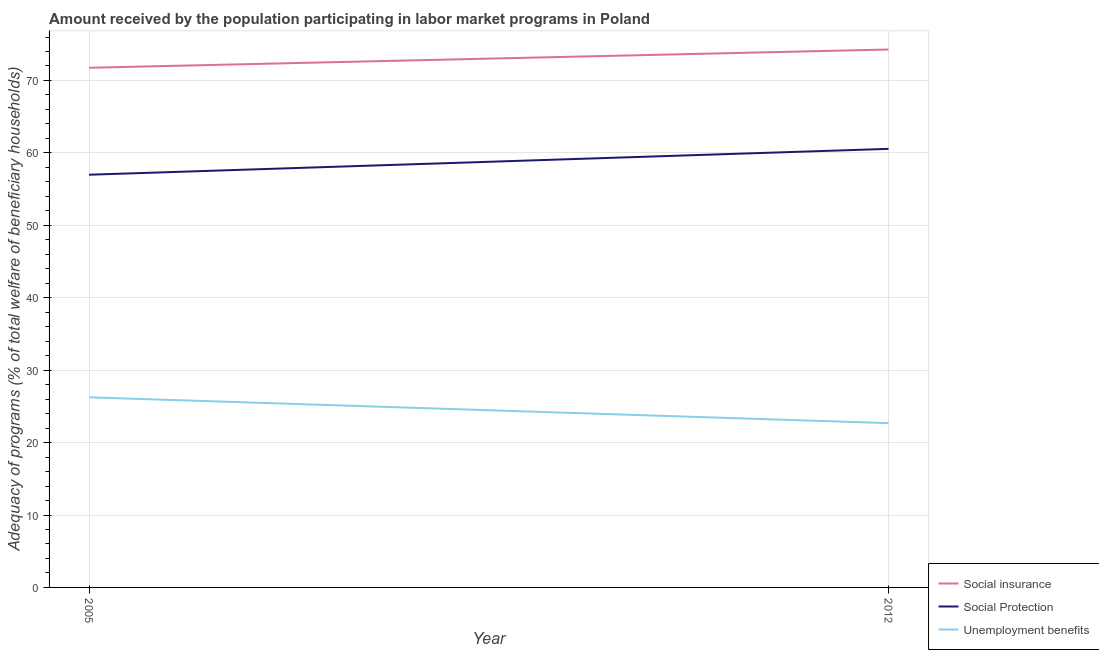How many different coloured lines are there?
Your answer should be compact. 3. Is the number of lines equal to the number of legend labels?
Offer a very short reply. Yes. What is the amount received by the population participating in unemployment benefits programs in 2012?
Provide a short and direct response. 22.68. Across all years, what is the maximum amount received by the population participating in unemployment benefits programs?
Ensure brevity in your answer.  26.25. Across all years, what is the minimum amount received by the population participating in social protection programs?
Offer a terse response. 56.99. In which year was the amount received by the population participating in social protection programs maximum?
Your response must be concise. 2012. In which year was the amount received by the population participating in social insurance programs minimum?
Offer a very short reply. 2005. What is the total amount received by the population participating in unemployment benefits programs in the graph?
Make the answer very short. 48.93. What is the difference between the amount received by the population participating in social protection programs in 2005 and that in 2012?
Your answer should be very brief. -3.57. What is the difference between the amount received by the population participating in unemployment benefits programs in 2012 and the amount received by the population participating in social insurance programs in 2005?
Offer a terse response. -49.07. What is the average amount received by the population participating in social protection programs per year?
Provide a succinct answer. 58.77. In the year 2012, what is the difference between the amount received by the population participating in social insurance programs and amount received by the population participating in social protection programs?
Make the answer very short. 13.72. What is the ratio of the amount received by the population participating in social protection programs in 2005 to that in 2012?
Your response must be concise. 0.94. Is it the case that in every year, the sum of the amount received by the population participating in social insurance programs and amount received by the population participating in social protection programs is greater than the amount received by the population participating in unemployment benefits programs?
Give a very brief answer. Yes. Does the amount received by the population participating in social insurance programs monotonically increase over the years?
Provide a short and direct response. Yes. Is the amount received by the population participating in social protection programs strictly greater than the amount received by the population participating in social insurance programs over the years?
Your response must be concise. No. How many lines are there?
Your answer should be very brief. 3. How many years are there in the graph?
Provide a succinct answer. 2. Are the values on the major ticks of Y-axis written in scientific E-notation?
Your answer should be very brief. No. What is the title of the graph?
Offer a very short reply. Amount received by the population participating in labor market programs in Poland. What is the label or title of the Y-axis?
Your answer should be very brief. Adequacy of programs (% of total welfare of beneficiary households). What is the Adequacy of programs (% of total welfare of beneficiary households) in Social insurance in 2005?
Provide a succinct answer. 71.75. What is the Adequacy of programs (% of total welfare of beneficiary households) of Social Protection in 2005?
Offer a terse response. 56.99. What is the Adequacy of programs (% of total welfare of beneficiary households) in Unemployment benefits in 2005?
Give a very brief answer. 26.25. What is the Adequacy of programs (% of total welfare of beneficiary households) in Social insurance in 2012?
Offer a very short reply. 74.28. What is the Adequacy of programs (% of total welfare of beneficiary households) of Social Protection in 2012?
Provide a short and direct response. 60.56. What is the Adequacy of programs (% of total welfare of beneficiary households) of Unemployment benefits in 2012?
Keep it short and to the point. 22.68. Across all years, what is the maximum Adequacy of programs (% of total welfare of beneficiary households) in Social insurance?
Your response must be concise. 74.28. Across all years, what is the maximum Adequacy of programs (% of total welfare of beneficiary households) of Social Protection?
Your response must be concise. 60.56. Across all years, what is the maximum Adequacy of programs (% of total welfare of beneficiary households) of Unemployment benefits?
Give a very brief answer. 26.25. Across all years, what is the minimum Adequacy of programs (% of total welfare of beneficiary households) of Social insurance?
Your answer should be very brief. 71.75. Across all years, what is the minimum Adequacy of programs (% of total welfare of beneficiary households) of Social Protection?
Give a very brief answer. 56.99. Across all years, what is the minimum Adequacy of programs (% of total welfare of beneficiary households) in Unemployment benefits?
Offer a very short reply. 22.68. What is the total Adequacy of programs (% of total welfare of beneficiary households) of Social insurance in the graph?
Keep it short and to the point. 146.03. What is the total Adequacy of programs (% of total welfare of beneficiary households) of Social Protection in the graph?
Give a very brief answer. 117.54. What is the total Adequacy of programs (% of total welfare of beneficiary households) of Unemployment benefits in the graph?
Your response must be concise. 48.93. What is the difference between the Adequacy of programs (% of total welfare of beneficiary households) in Social insurance in 2005 and that in 2012?
Ensure brevity in your answer.  -2.52. What is the difference between the Adequacy of programs (% of total welfare of beneficiary households) of Social Protection in 2005 and that in 2012?
Offer a terse response. -3.57. What is the difference between the Adequacy of programs (% of total welfare of beneficiary households) of Unemployment benefits in 2005 and that in 2012?
Ensure brevity in your answer.  3.57. What is the difference between the Adequacy of programs (% of total welfare of beneficiary households) in Social insurance in 2005 and the Adequacy of programs (% of total welfare of beneficiary households) in Social Protection in 2012?
Provide a succinct answer. 11.2. What is the difference between the Adequacy of programs (% of total welfare of beneficiary households) in Social insurance in 2005 and the Adequacy of programs (% of total welfare of beneficiary households) in Unemployment benefits in 2012?
Give a very brief answer. 49.07. What is the difference between the Adequacy of programs (% of total welfare of beneficiary households) in Social Protection in 2005 and the Adequacy of programs (% of total welfare of beneficiary households) in Unemployment benefits in 2012?
Offer a terse response. 34.3. What is the average Adequacy of programs (% of total welfare of beneficiary households) in Social insurance per year?
Ensure brevity in your answer.  73.01. What is the average Adequacy of programs (% of total welfare of beneficiary households) in Social Protection per year?
Your answer should be compact. 58.77. What is the average Adequacy of programs (% of total welfare of beneficiary households) of Unemployment benefits per year?
Keep it short and to the point. 24.47. In the year 2005, what is the difference between the Adequacy of programs (% of total welfare of beneficiary households) in Social insurance and Adequacy of programs (% of total welfare of beneficiary households) in Social Protection?
Offer a terse response. 14.77. In the year 2005, what is the difference between the Adequacy of programs (% of total welfare of beneficiary households) of Social insurance and Adequacy of programs (% of total welfare of beneficiary households) of Unemployment benefits?
Offer a very short reply. 45.5. In the year 2005, what is the difference between the Adequacy of programs (% of total welfare of beneficiary households) in Social Protection and Adequacy of programs (% of total welfare of beneficiary households) in Unemployment benefits?
Give a very brief answer. 30.74. In the year 2012, what is the difference between the Adequacy of programs (% of total welfare of beneficiary households) in Social insurance and Adequacy of programs (% of total welfare of beneficiary households) in Social Protection?
Make the answer very short. 13.72. In the year 2012, what is the difference between the Adequacy of programs (% of total welfare of beneficiary households) in Social insurance and Adequacy of programs (% of total welfare of beneficiary households) in Unemployment benefits?
Keep it short and to the point. 51.59. In the year 2012, what is the difference between the Adequacy of programs (% of total welfare of beneficiary households) of Social Protection and Adequacy of programs (% of total welfare of beneficiary households) of Unemployment benefits?
Provide a short and direct response. 37.87. What is the ratio of the Adequacy of programs (% of total welfare of beneficiary households) in Social Protection in 2005 to that in 2012?
Your answer should be compact. 0.94. What is the ratio of the Adequacy of programs (% of total welfare of beneficiary households) of Unemployment benefits in 2005 to that in 2012?
Provide a short and direct response. 1.16. What is the difference between the highest and the second highest Adequacy of programs (% of total welfare of beneficiary households) in Social insurance?
Keep it short and to the point. 2.52. What is the difference between the highest and the second highest Adequacy of programs (% of total welfare of beneficiary households) of Social Protection?
Your answer should be compact. 3.57. What is the difference between the highest and the second highest Adequacy of programs (% of total welfare of beneficiary households) of Unemployment benefits?
Offer a terse response. 3.57. What is the difference between the highest and the lowest Adequacy of programs (% of total welfare of beneficiary households) of Social insurance?
Provide a short and direct response. 2.52. What is the difference between the highest and the lowest Adequacy of programs (% of total welfare of beneficiary households) in Social Protection?
Provide a succinct answer. 3.57. What is the difference between the highest and the lowest Adequacy of programs (% of total welfare of beneficiary households) of Unemployment benefits?
Your response must be concise. 3.57. 